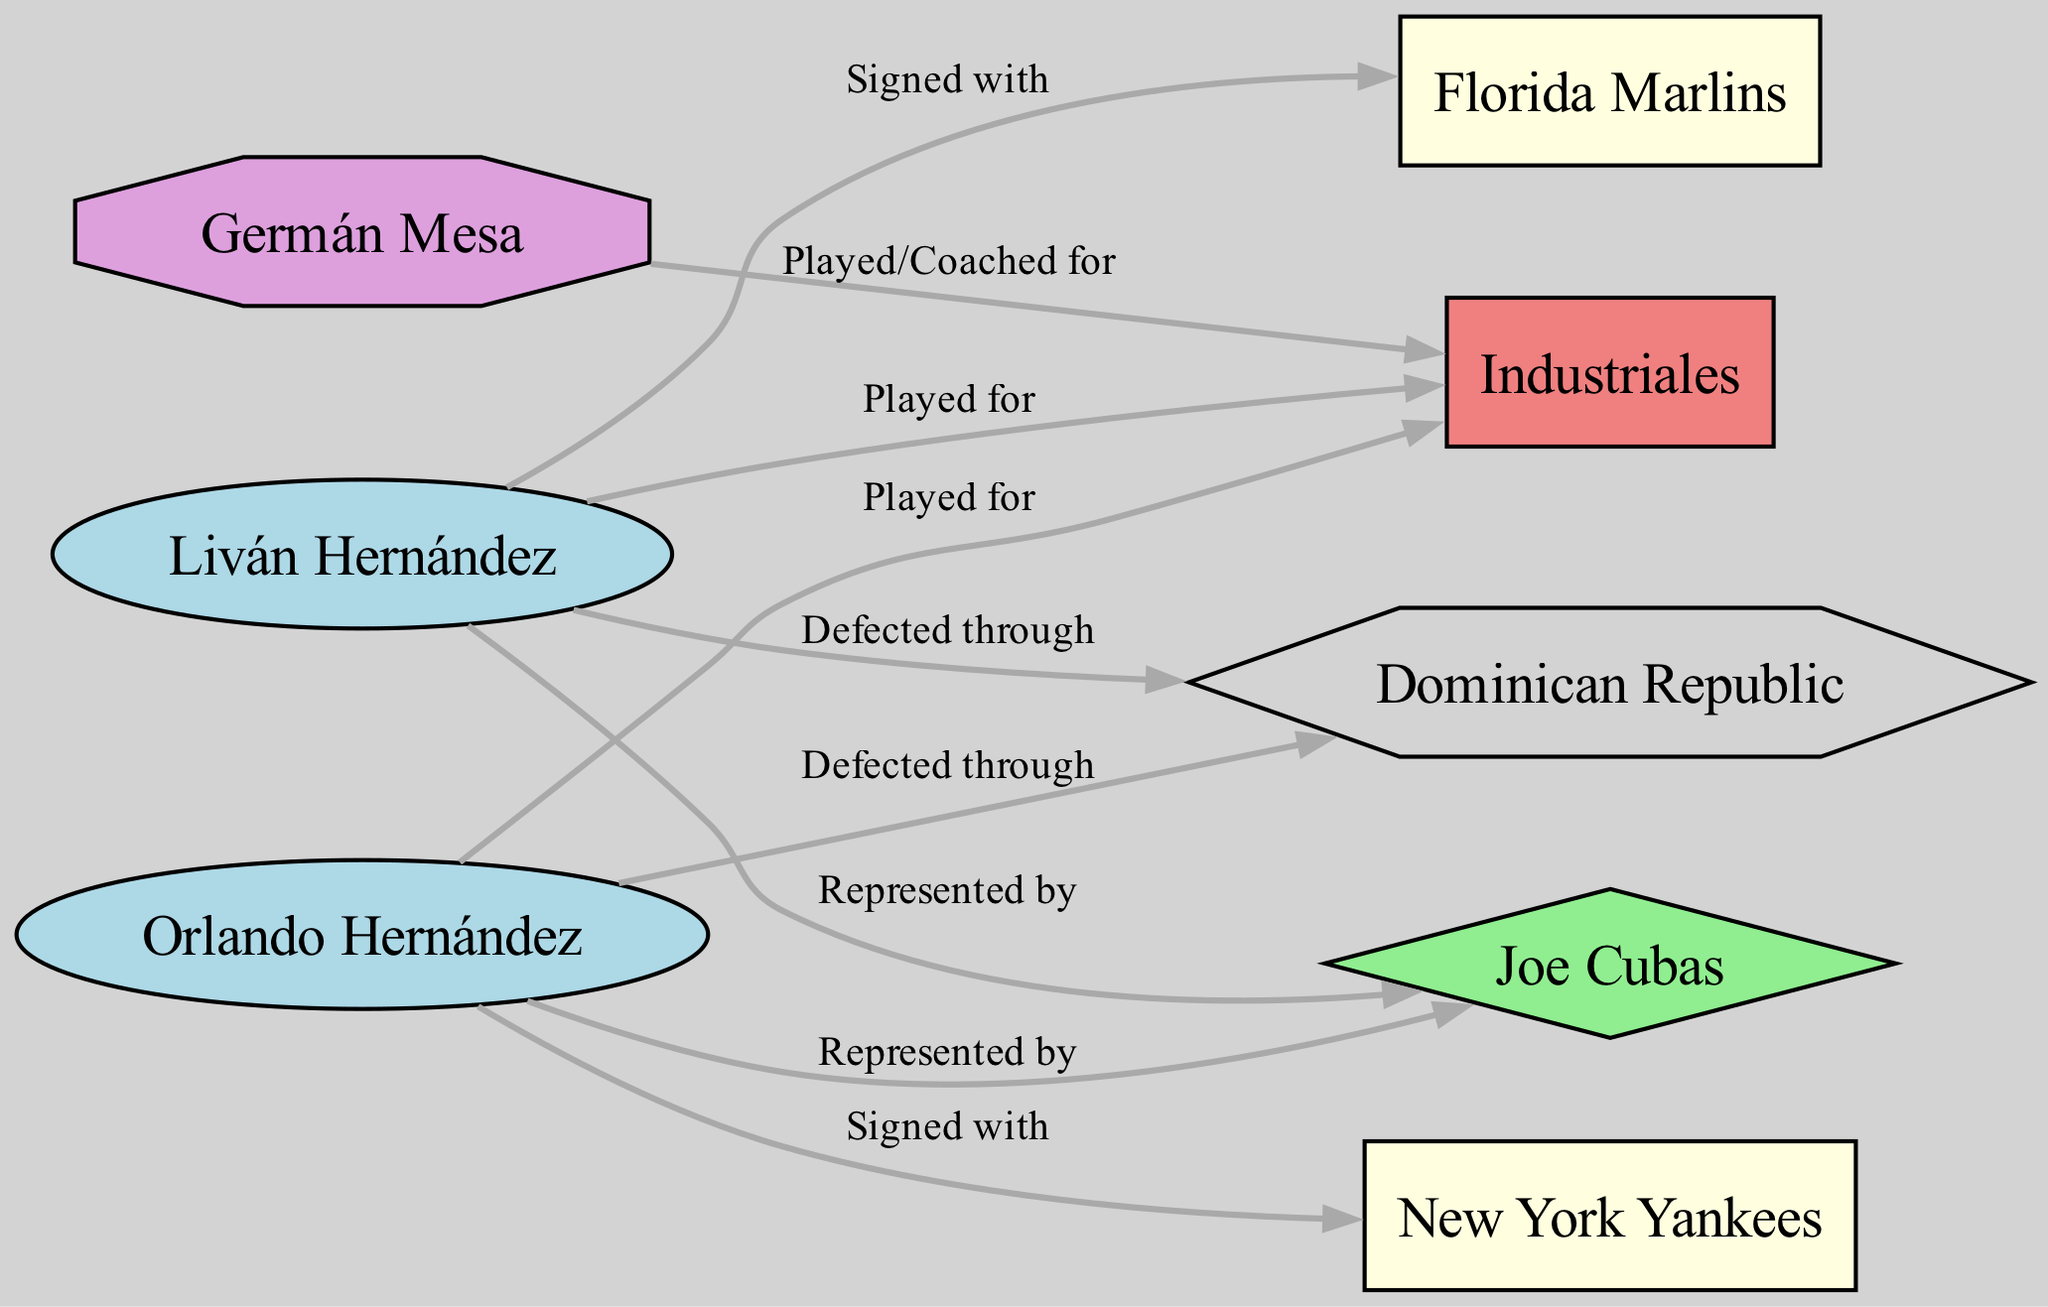What are the total number of players represented in the diagram? By counting the nodes labeled as "Player," we identify Orlando Hernández, Liván Hernández, and Germán Mesa. Thus, the total is 3 players.
Answer: 3 Which MLB Team did Orlando Hernández sign with? We look at the edge connected to Orlando Hernández where it states "Signed with" and see that it points to the New York Yankees.
Answer: New York Yankees How many edges are there between players and their agents in the diagram? The edges that show relationships between players and their agents are the ones connecting Orlando Hernández and Liván Hernández to Joe Cubas. There are 2 edges representing these relationships.
Answer: 2 Which Cuban Team did Liván Hernández play for? We follow the edge labeled "Played for" that connects Liván Hernández to a node and see that it points to Industriales.
Answer: Industriales What is the type of node that represents the agent in the diagram? By looking at the node labeled Joe Cubas, we identify its type, which has been categorized as "Agent" in the network diagram.
Answer: Agent How many players defected through the Dominican Republic? We check each player's representation with the edge "Defected through." Both Orlando Hernández and Liván Hernández have edges pointing to the Dominican Republic, showing that both defected through there, resulting in a total of 2 players.
Answer: 2 What type of relationship exists between Germán Mesa and Industriales? The edge connecting Germán Mesa and Industriales states "Played/Coached for," indicating a dual role in his relationship with this Cuban team.
Answer: Played/Coached for Which transit country is mentioned in the relationships of the players? By reviewing the diagram, we note that the only transit country mentioned in connection with the players is the Dominican Republic as shown by the respective edges.
Answer: Dominican Republic 